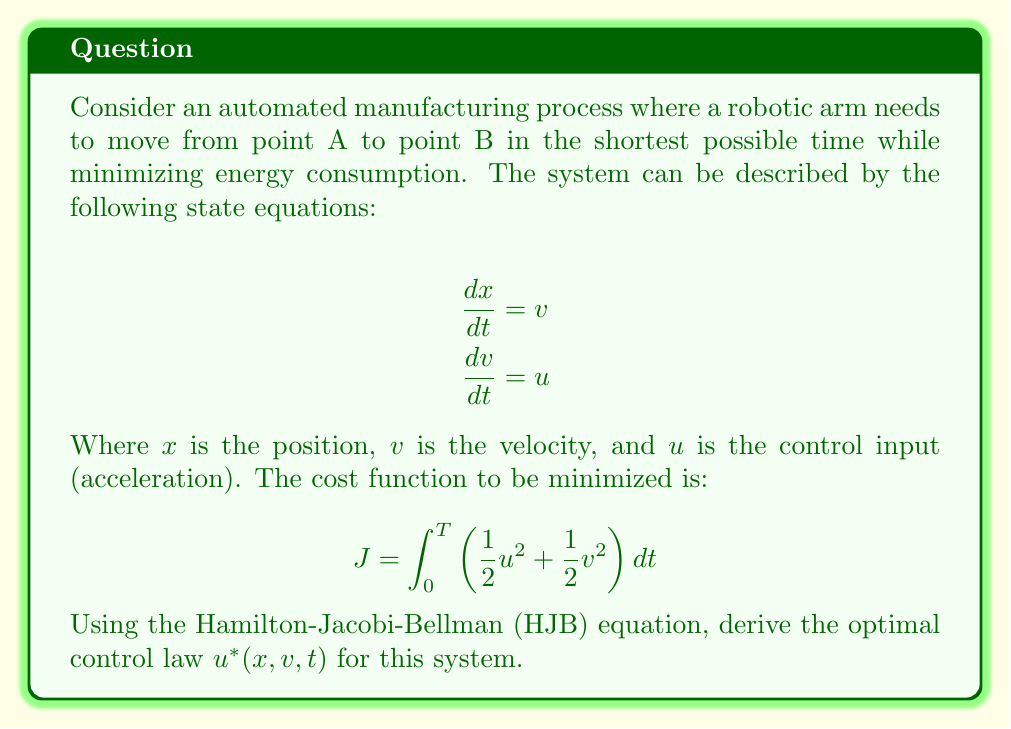Show me your answer to this math problem. To solve this problem using the Hamilton-Jacobi-Bellman equation, we'll follow these steps:

1) First, we define the value function $V(x,v,t)$ as the minimum cost-to-go from the current state $(x,v)$ at time $t$ to the final state.

2) The HJB equation for this problem is:

   $$-\frac{\partial V}{\partial t} = \min_u \left[\frac{1}{2}u^2 + \frac{1}{2}v^2 + \frac{\partial V}{\partial x}v + \frac{\partial V}{\partial v}u\right]$$

3) To find the minimum, we differentiate the right-hand side with respect to $u$ and set it to zero:

   $$u + \frac{\partial V}{\partial v} = 0$$

4) Solving for $u$, we get the optimal control law:

   $$u^*(x,v,t) = -\frac{\partial V}{\partial v}$$

5) Substituting this back into the HJB equation:

   $$-\frac{\partial V}{\partial t} = \frac{1}{2}\left(-\frac{\partial V}{\partial v}\right)^2 + \frac{1}{2}v^2 + \frac{\partial V}{\partial x}v$$

6) We can guess a quadratic form for the value function:

   $$V(x,v,t) = \frac{1}{2}a(t)x^2 + b(t)xv + \frac{1}{2}c(t)v^2 + d(t)x + e(t)v + f(t)$$

7) Substituting this into the HJB equation and equating coefficients, we get a system of differential equations for $a(t), b(t), c(t), d(t), e(t),$ and $f(t)$.

8) Solving these differential equations with appropriate boundary conditions would give us the exact form of $V(x,v,t)$.

9) Once we have $V(x,v,t)$, we can substitute it into the expression for $u^*(x,v,t)$ from step 4:

   $$u^*(x,v,t) = -\frac{\partial V}{\partial v} = -(b(t)x + c(t)v + e(t))$$

This is the optimal control law for the system.
Answer: The optimal control law for the system is:

$$u^*(x,v,t) = -(b(t)x + c(t)v + e(t))$$

where $b(t)$, $c(t)$, and $e(t)$ are functions determined by solving the system of differential equations resulting from the HJB equation. 